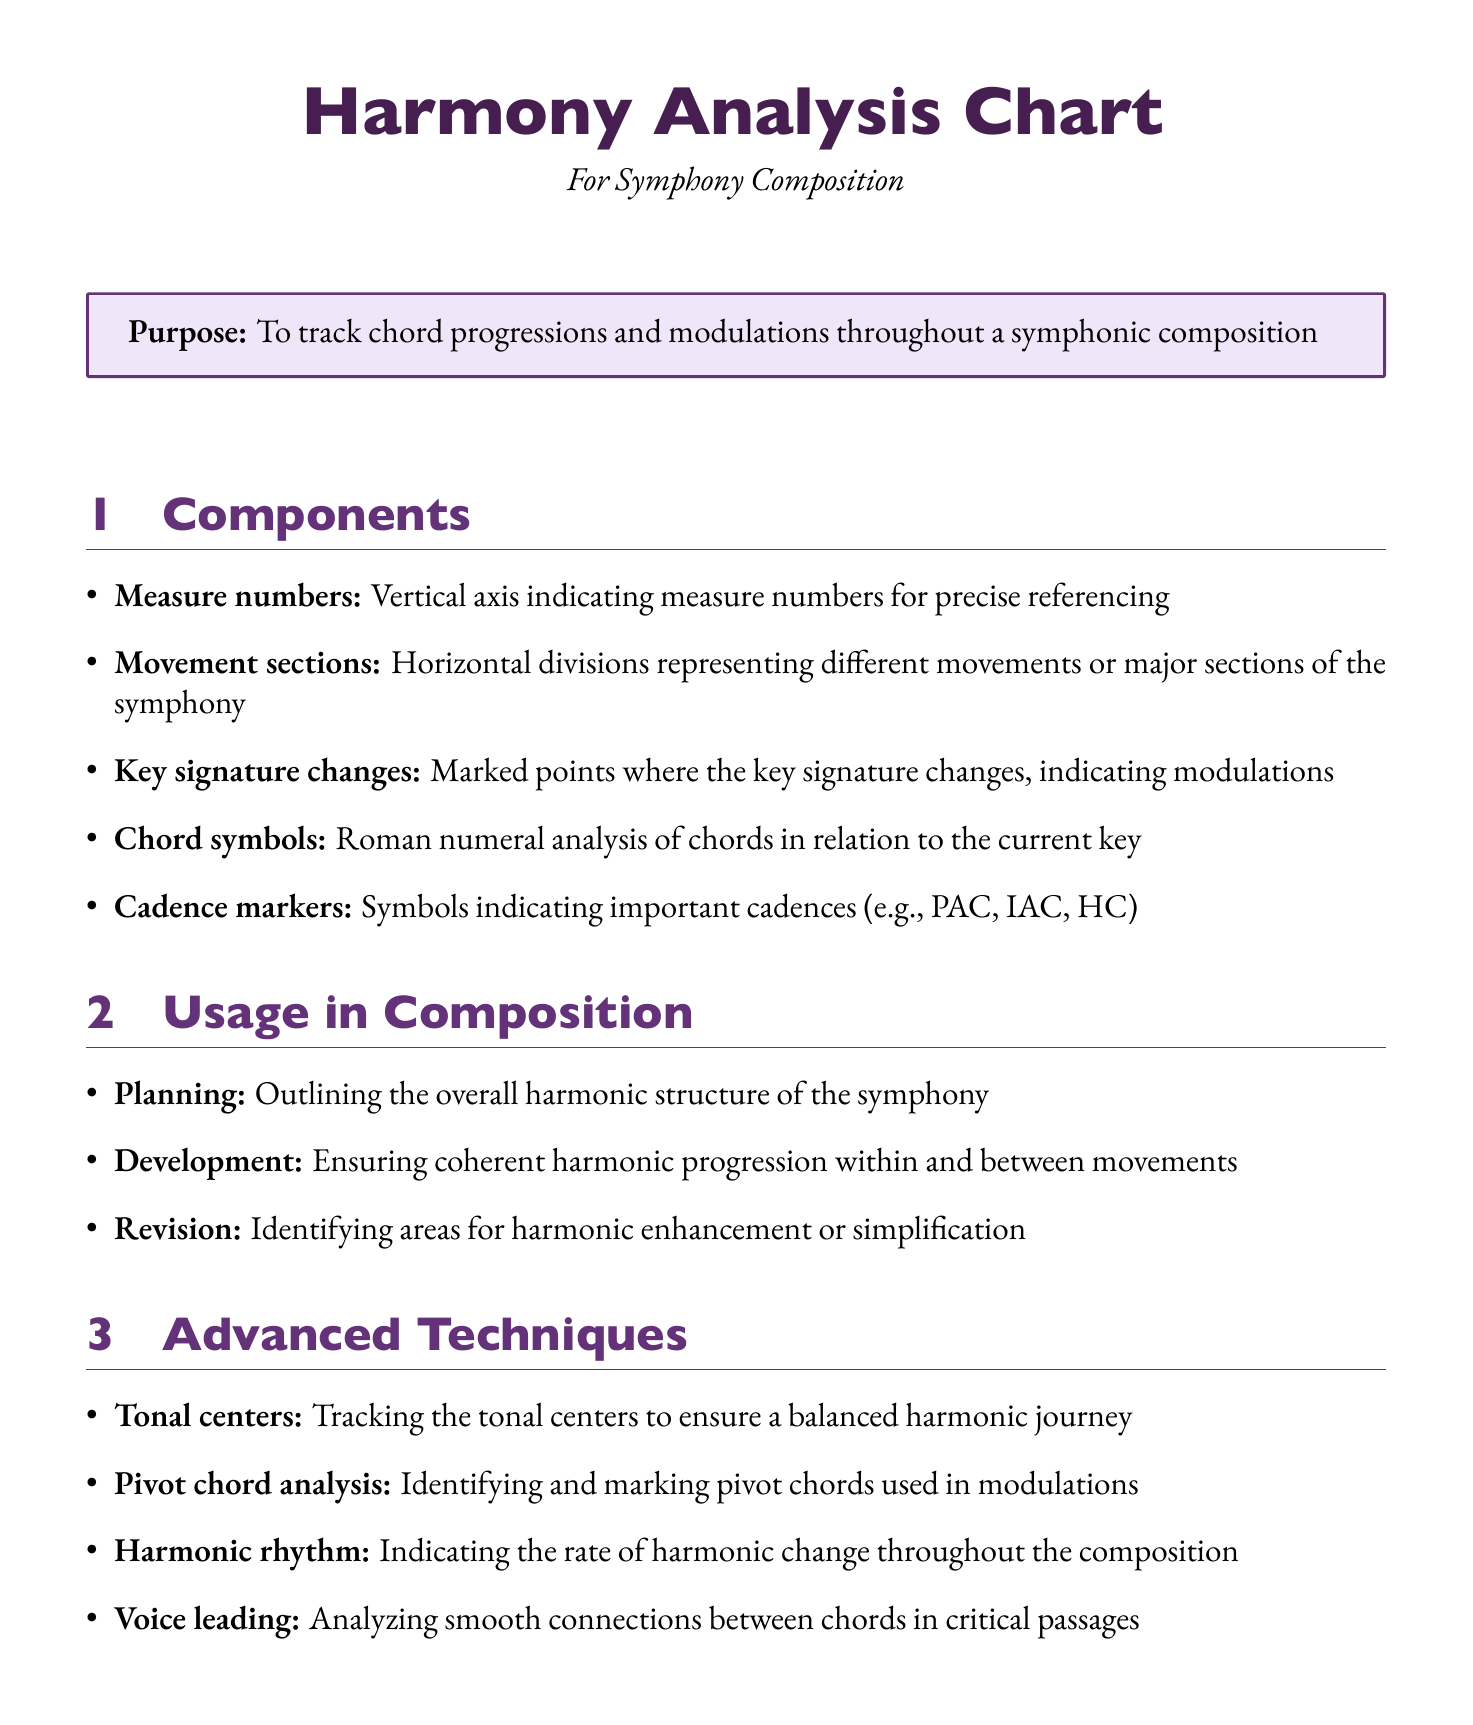What is the purpose of the Harmony Analysis Chart? The purpose is to track chord progressions and modulations throughout a symphonic composition.
Answer: To track chord progressions and modulations throughout a symphonic composition How many components are listed in the document? The document lists five components under the "Components" section.
Answer: Five What does the "Cadence markers" represent? Cadence markers indicate important cadences such as PAC, IAC, and HC.
Answer: Symbols indicating important cadences (e.g., PAC, IAC, HC) Which composer is associated with the Symphony No. 4 in E minor? The composer of this work is Johannes Brahms.
Answer: Johannes Brahms What advanced technique is used to identify and mark pivot chords? The technique used for this purpose is called pivot chord analysis.
Answer: Pivot chord analysis In which stage of composition is the Harmony Analysis Chart used for ensuring coherent harmonic progression? This application is relevant during the development stage of composition.
Answer: Development What software tool is an open-source option? The open-source option mentioned in the document is MuseScore.
Answer: MuseScore What is one teaching application context mentioned in the document? Composition classes are one of the contexts where the Harmony Analysis Chart is used.
Answer: Composition classes 